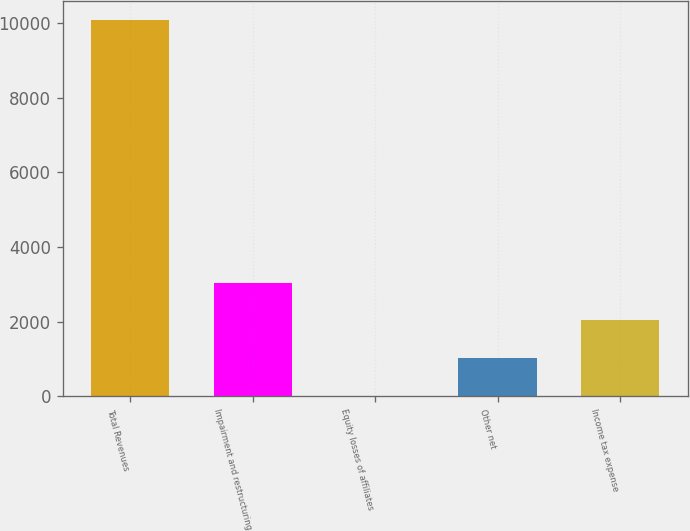Convert chart to OTSL. <chart><loc_0><loc_0><loc_500><loc_500><bar_chart><fcel>Total Revenues<fcel>Impairment and restructuring<fcel>Equity losses of affiliates<fcel>Other net<fcel>Income tax expense<nl><fcel>10074<fcel>3034.1<fcel>17<fcel>1022.7<fcel>2028.4<nl></chart> 